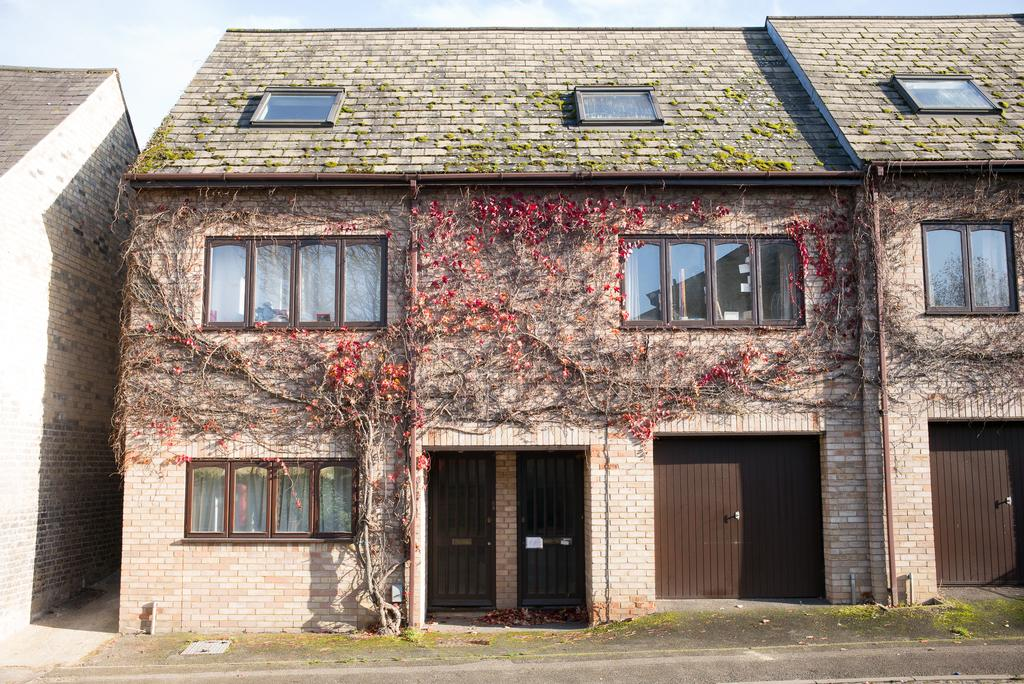What type of pathway is visible in the image? There is a road in the image. What natural element can be seen in the image? There is a tree in the image. What type of structures are present in the image? There are houses with windows and doors in the image. What is visible at the top of the image? The sky is visible at the top of the image. What can be observed in the sky? There are clouds in the sky. What type of disease is affecting the tree in the image? There is no disease affecting the tree in the image; it appears to be a healthy tree. What color is the pencil used to draw the houses in the image? There is no pencil present in the image; it is a photograph or digital representation of the scene. 